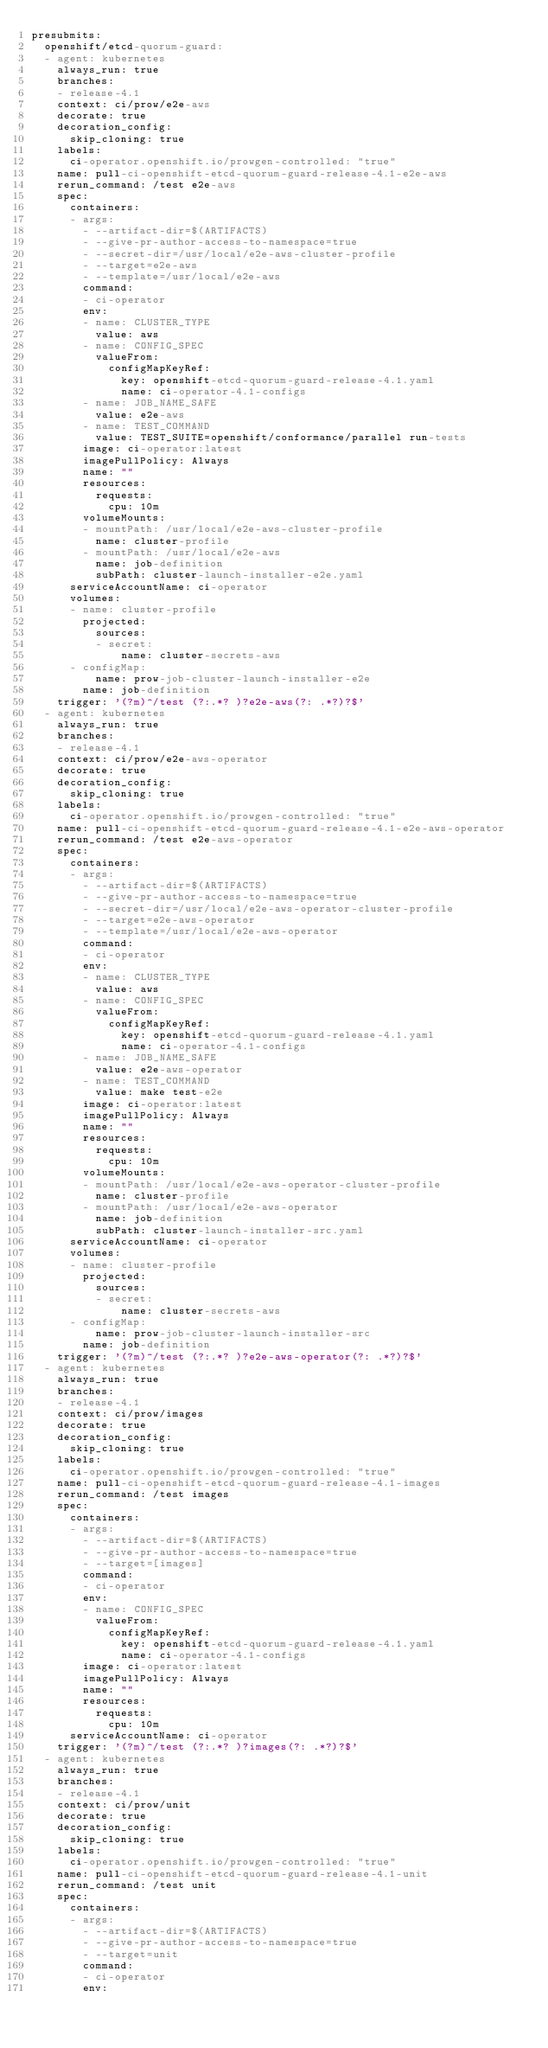<code> <loc_0><loc_0><loc_500><loc_500><_YAML_>presubmits:
  openshift/etcd-quorum-guard:
  - agent: kubernetes
    always_run: true
    branches:
    - release-4.1
    context: ci/prow/e2e-aws
    decorate: true
    decoration_config:
      skip_cloning: true
    labels:
      ci-operator.openshift.io/prowgen-controlled: "true"
    name: pull-ci-openshift-etcd-quorum-guard-release-4.1-e2e-aws
    rerun_command: /test e2e-aws
    spec:
      containers:
      - args:
        - --artifact-dir=$(ARTIFACTS)
        - --give-pr-author-access-to-namespace=true
        - --secret-dir=/usr/local/e2e-aws-cluster-profile
        - --target=e2e-aws
        - --template=/usr/local/e2e-aws
        command:
        - ci-operator
        env:
        - name: CLUSTER_TYPE
          value: aws
        - name: CONFIG_SPEC
          valueFrom:
            configMapKeyRef:
              key: openshift-etcd-quorum-guard-release-4.1.yaml
              name: ci-operator-4.1-configs
        - name: JOB_NAME_SAFE
          value: e2e-aws
        - name: TEST_COMMAND
          value: TEST_SUITE=openshift/conformance/parallel run-tests
        image: ci-operator:latest
        imagePullPolicy: Always
        name: ""
        resources:
          requests:
            cpu: 10m
        volumeMounts:
        - mountPath: /usr/local/e2e-aws-cluster-profile
          name: cluster-profile
        - mountPath: /usr/local/e2e-aws
          name: job-definition
          subPath: cluster-launch-installer-e2e.yaml
      serviceAccountName: ci-operator
      volumes:
      - name: cluster-profile
        projected:
          sources:
          - secret:
              name: cluster-secrets-aws
      - configMap:
          name: prow-job-cluster-launch-installer-e2e
        name: job-definition
    trigger: '(?m)^/test (?:.*? )?e2e-aws(?: .*?)?$'
  - agent: kubernetes
    always_run: true
    branches:
    - release-4.1
    context: ci/prow/e2e-aws-operator
    decorate: true
    decoration_config:
      skip_cloning: true
    labels:
      ci-operator.openshift.io/prowgen-controlled: "true"
    name: pull-ci-openshift-etcd-quorum-guard-release-4.1-e2e-aws-operator
    rerun_command: /test e2e-aws-operator
    spec:
      containers:
      - args:
        - --artifact-dir=$(ARTIFACTS)
        - --give-pr-author-access-to-namespace=true
        - --secret-dir=/usr/local/e2e-aws-operator-cluster-profile
        - --target=e2e-aws-operator
        - --template=/usr/local/e2e-aws-operator
        command:
        - ci-operator
        env:
        - name: CLUSTER_TYPE
          value: aws
        - name: CONFIG_SPEC
          valueFrom:
            configMapKeyRef:
              key: openshift-etcd-quorum-guard-release-4.1.yaml
              name: ci-operator-4.1-configs
        - name: JOB_NAME_SAFE
          value: e2e-aws-operator
        - name: TEST_COMMAND
          value: make test-e2e
        image: ci-operator:latest
        imagePullPolicy: Always
        name: ""
        resources:
          requests:
            cpu: 10m
        volumeMounts:
        - mountPath: /usr/local/e2e-aws-operator-cluster-profile
          name: cluster-profile
        - mountPath: /usr/local/e2e-aws-operator
          name: job-definition
          subPath: cluster-launch-installer-src.yaml
      serviceAccountName: ci-operator
      volumes:
      - name: cluster-profile
        projected:
          sources:
          - secret:
              name: cluster-secrets-aws
      - configMap:
          name: prow-job-cluster-launch-installer-src
        name: job-definition
    trigger: '(?m)^/test (?:.*? )?e2e-aws-operator(?: .*?)?$'
  - agent: kubernetes
    always_run: true
    branches:
    - release-4.1
    context: ci/prow/images
    decorate: true
    decoration_config:
      skip_cloning: true
    labels:
      ci-operator.openshift.io/prowgen-controlled: "true"
    name: pull-ci-openshift-etcd-quorum-guard-release-4.1-images
    rerun_command: /test images
    spec:
      containers:
      - args:
        - --artifact-dir=$(ARTIFACTS)
        - --give-pr-author-access-to-namespace=true
        - --target=[images]
        command:
        - ci-operator
        env:
        - name: CONFIG_SPEC
          valueFrom:
            configMapKeyRef:
              key: openshift-etcd-quorum-guard-release-4.1.yaml
              name: ci-operator-4.1-configs
        image: ci-operator:latest
        imagePullPolicy: Always
        name: ""
        resources:
          requests:
            cpu: 10m
      serviceAccountName: ci-operator
    trigger: '(?m)^/test (?:.*? )?images(?: .*?)?$'
  - agent: kubernetes
    always_run: true
    branches:
    - release-4.1
    context: ci/prow/unit
    decorate: true
    decoration_config:
      skip_cloning: true
    labels:
      ci-operator.openshift.io/prowgen-controlled: "true"
    name: pull-ci-openshift-etcd-quorum-guard-release-4.1-unit
    rerun_command: /test unit
    spec:
      containers:
      - args:
        - --artifact-dir=$(ARTIFACTS)
        - --give-pr-author-access-to-namespace=true
        - --target=unit
        command:
        - ci-operator
        env:</code> 